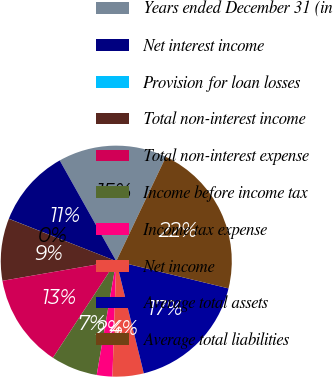Convert chart to OTSL. <chart><loc_0><loc_0><loc_500><loc_500><pie_chart><fcel>Years ended December 31 (in<fcel>Net interest income<fcel>Provision for loan losses<fcel>Total non-interest income<fcel>Total non-interest expense<fcel>Income before income tax<fcel>Income tax expense<fcel>Net income<fcel>Average total assets<fcel>Average total liabilities<nl><fcel>15.21%<fcel>10.87%<fcel>0.01%<fcel>8.7%<fcel>13.04%<fcel>6.53%<fcel>2.18%<fcel>4.36%<fcel>17.38%<fcel>21.72%<nl></chart> 